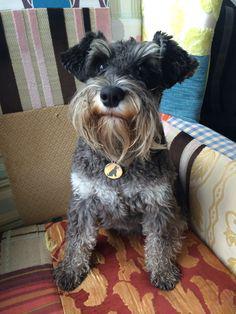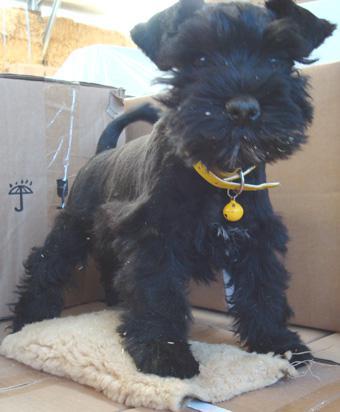The first image is the image on the left, the second image is the image on the right. Given the left and right images, does the statement "the dog in the image on the left side is visibly eating from a bowl on the floor" hold true? Answer yes or no. No. The first image is the image on the left, the second image is the image on the right. Examine the images to the left and right. Is the description "One dog is eating and the other dog is not near food." accurate? Answer yes or no. No. 